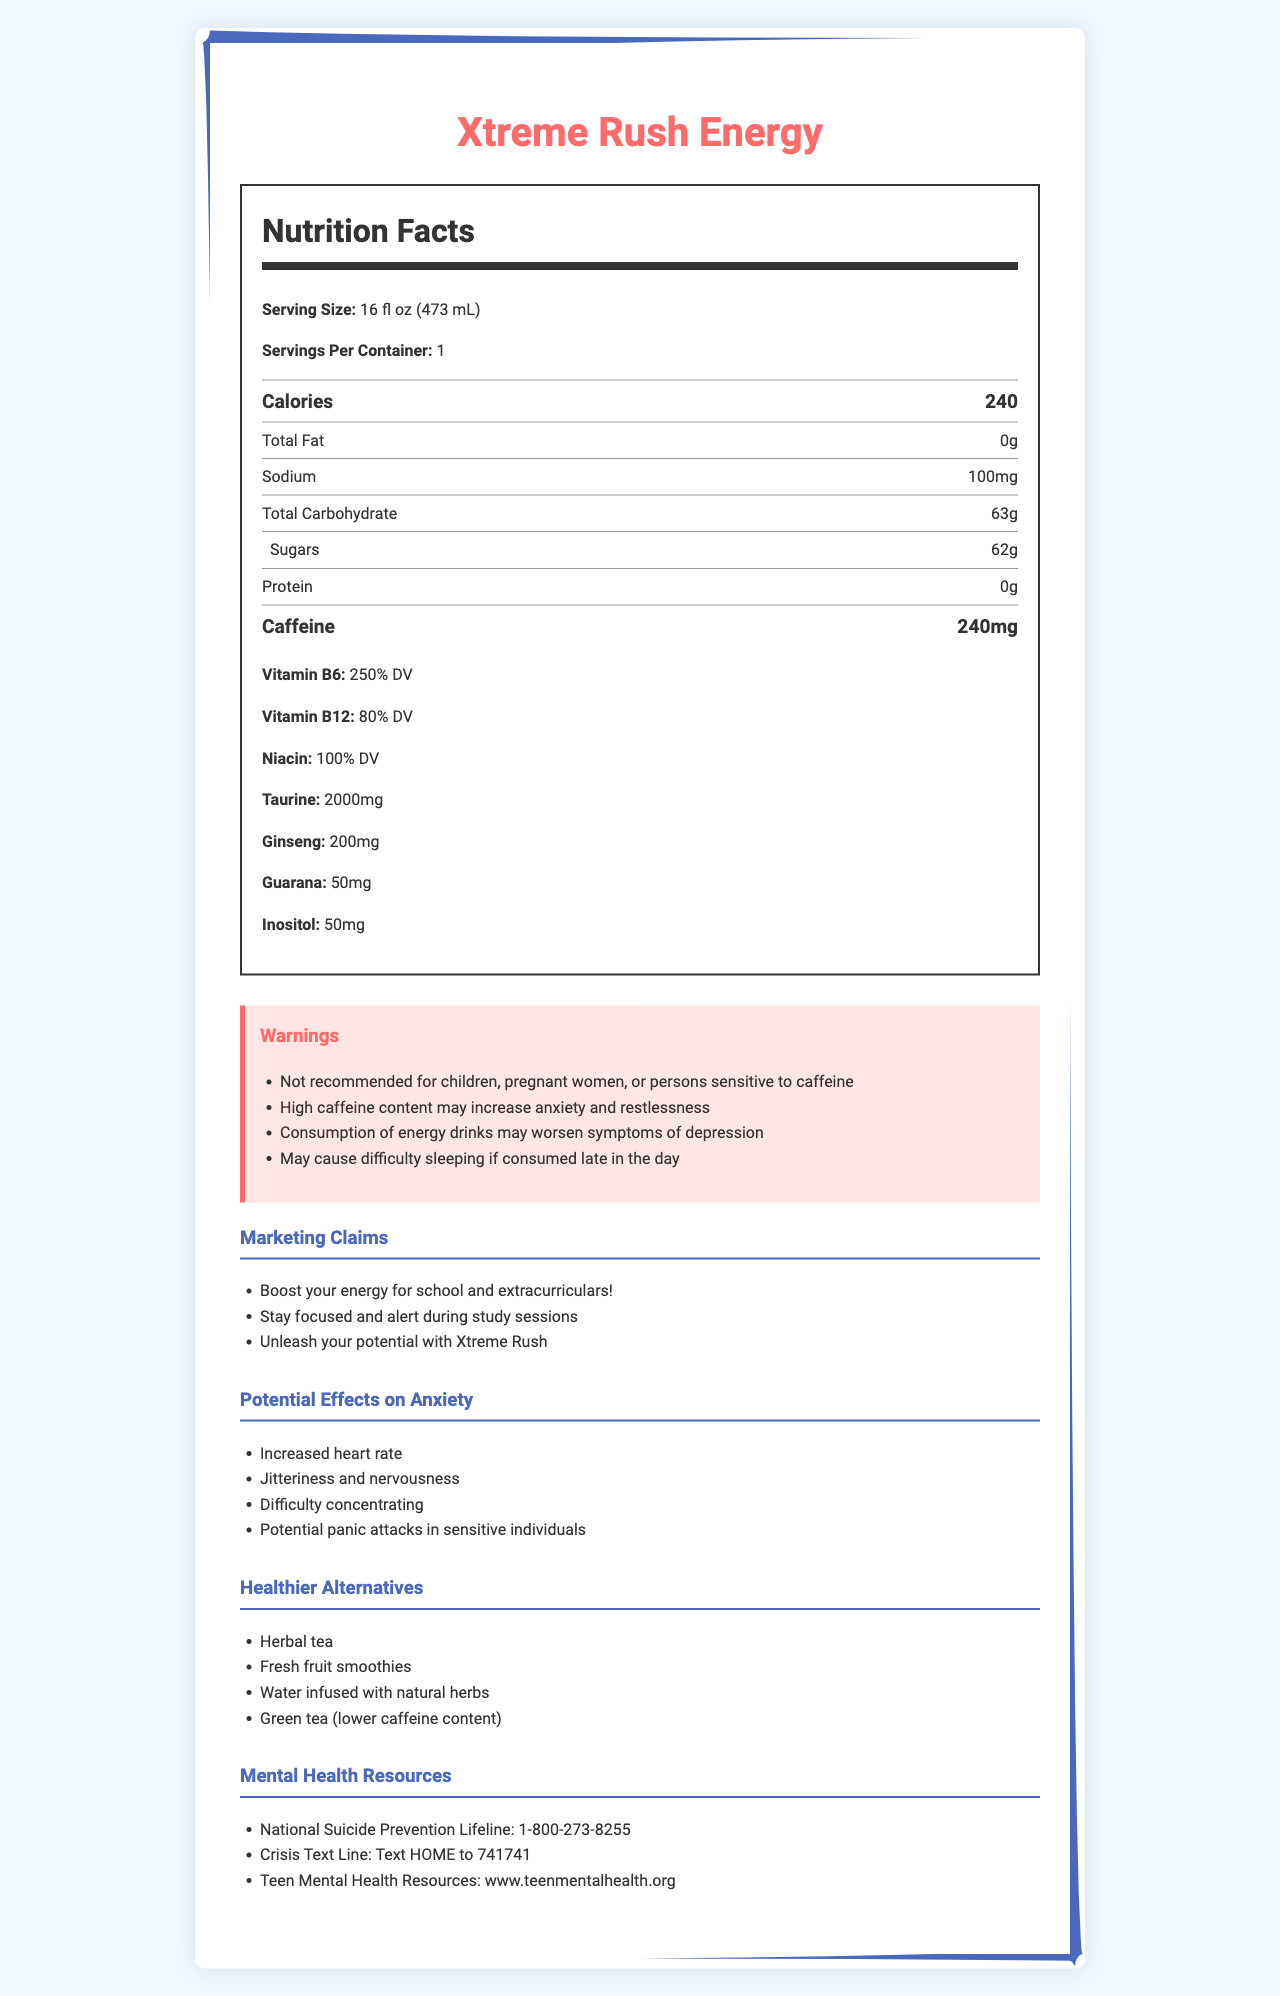what is the product name? The product name is displayed prominently at the top of the document.
Answer: Xtreme Rush Energy what is the serving size for Xtreme Rush Energy? The serving size is listed under the Nutrition Facts section as 16 fl oz (473 mL).
Answer: 16 fl oz (473 mL) how many calories are in one serving of Xtreme Rush Energy? The document states that there are 240 calories per serving under the large, bold "Calories" label.
Answer: 240 what is the caffeine content of the drink? The nutrition label lists caffeine content as 240mg in a larger font at the bottom of the nutrition content table.
Answer: 240mg how many servings are there in one container of Xtreme Rush Energy? The document specifies "Servings Per Container: 1" under the Nutrition Facts section.
Answer: 1 how much sugar does Xtreme Rush Energy contain? The nutrition label indicates that there are 62 grams of sugars per serving.
Answer: 62g which vitamin is present at 250% DV in the drink? Under the Nutrition Facts, it’s indicated that Vitamin B6 is present at 250% DV.
Answer: Vitamin B6 what are some potential effects of caffeine on anxiety mentioned in the document? These potential effects on anxiety are listed under the section titled "Potential Effects on Anxiety".
Answer: Increased heart rate, Jitteriness and nervousness, Difficulty concentrating, Potential panic attacks in sensitive individuals what are some healthier alternatives to Xtreme Rush Energy mentioned in the document? Under the "Healthier Alternatives" section, these options are provided as suggestions.
Answer: Herbal tea, Fresh fruit smoothies, Water infused with natural herbs, Green tea (lower caffeine content) What are the marketing claims made for Xtreme Rush Energy? These marketing claims are listed in the "Marketing Claims" section.
Answer: Boost your energy for school and extracurriculars!, Stay focused and alert during study sessions, Unleash your potential with Xtreme Rush which of the following is a warning associated with Xtreme Rush Energy? A. It may cause difficulty sleeping if consumed late in the day B. It is safe for children C. It contains no sugar Option A "It may cause difficulty sleeping if consumed late in the day" is listed under the "Warnings" section. Options B and C are false.
Answer: A how much sodium does one serving of Xtreme Rush Energy contain? A. 50mg B. 100mg C. 200mg D. 300mg The document lists sodium content as 100mg per serving under the Nutrition Facts section.
Answer: B is Xtreme Rush Energy recommended for children? The warning section of the document explicitly states "Not recommended for children".
Answer: No does Xtreme Rush Energy contain any protein? The Nutrition Facts section indicates that the drink contains 0g of protein.
Answer: No describe the main idea of the document. This summary covers the key sections displayed in the document: nutrition facts, warnings, potential effects on anxiety, healthier alternatives, marketing claims, and mental health resources.
Answer: The document provides detailed nutritional information about Xtreme Rush Energy, including calorie count, caffeine content, and vitamins. It highlights warnings, potential effects on anxiety, and offers healthier alternatives and mental health resources. It also includes marketing claims directed at teens. how does planting and nurturing plants help with anxiety and depression? The provided document does not contain any information about the relationship between planting and nurturing plants and managing anxiety and depression.
Answer: Not enough information 